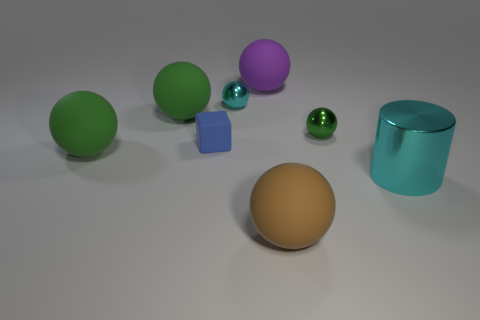There is a cyan metallic object that is the same shape as the large brown thing; what size is it?
Your answer should be compact. Small. What material is the ball in front of the large cyan metal thing?
Make the answer very short. Rubber. How many tiny objects are either cyan metal objects or brown metallic objects?
Your answer should be compact. 1. Does the green matte sphere that is behind the cube have the same size as the tiny rubber cube?
Make the answer very short. No. What number of other things are there of the same color as the tiny matte cube?
Make the answer very short. 0. What is the purple ball made of?
Make the answer very short. Rubber. There is a big thing that is both to the right of the cyan sphere and behind the cylinder; what is its material?
Offer a very short reply. Rubber. How many things are either cyan metallic spheres that are left of the metallic cylinder or tiny metal balls?
Make the answer very short. 2. Do the tiny matte block and the big shiny thing have the same color?
Offer a terse response. No. Is there a green matte object that has the same size as the brown rubber sphere?
Offer a terse response. Yes. 